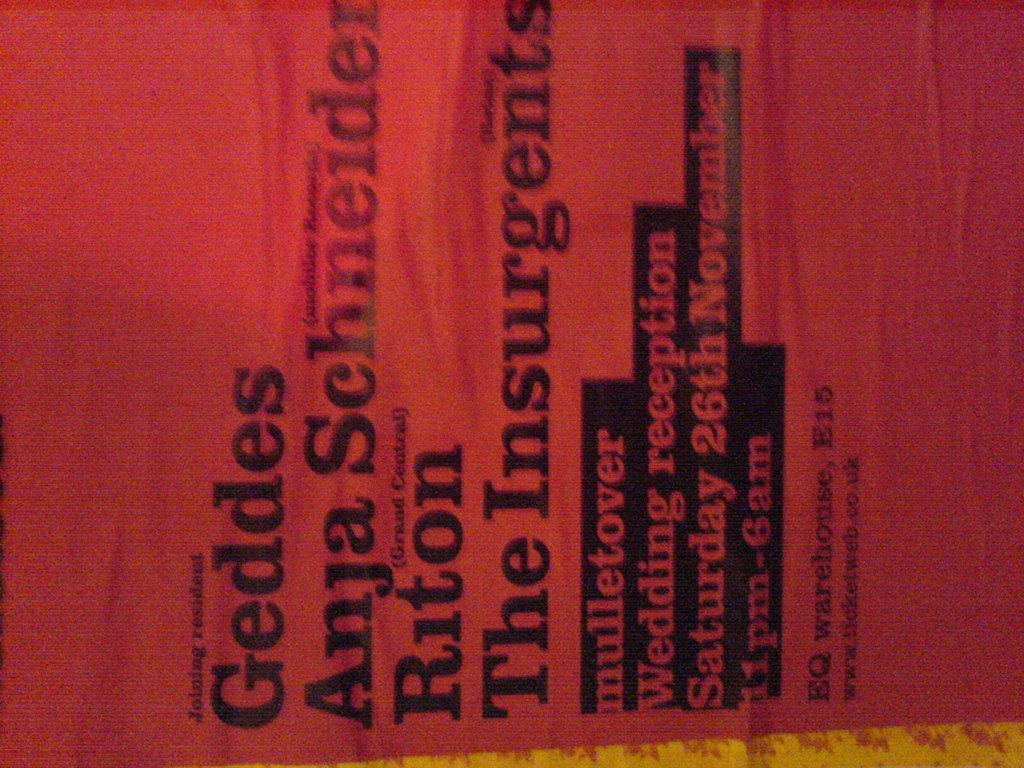<image>
Offer a succinct explanation of the picture presented. a red piece of fabric that says Geddes is laying sideways on a table 